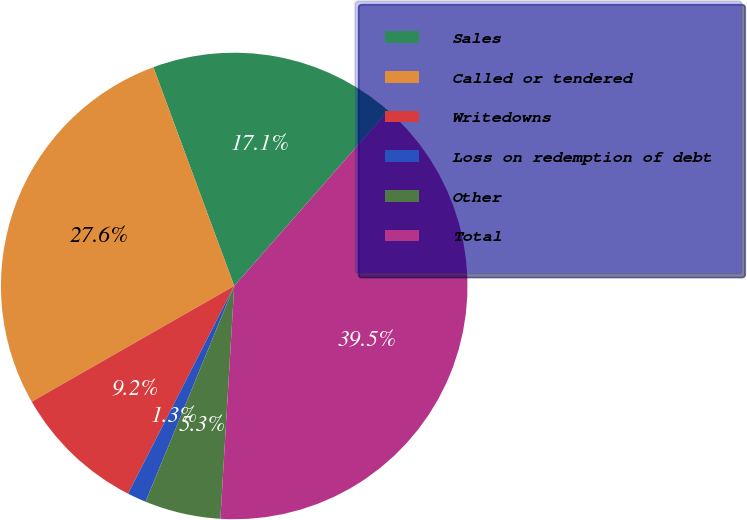Convert chart. <chart><loc_0><loc_0><loc_500><loc_500><pie_chart><fcel>Sales<fcel>Called or tendered<fcel>Writedowns<fcel>Loss on redemption of debt<fcel>Other<fcel>Total<nl><fcel>17.11%<fcel>27.63%<fcel>9.21%<fcel>1.32%<fcel>5.26%<fcel>39.47%<nl></chart> 